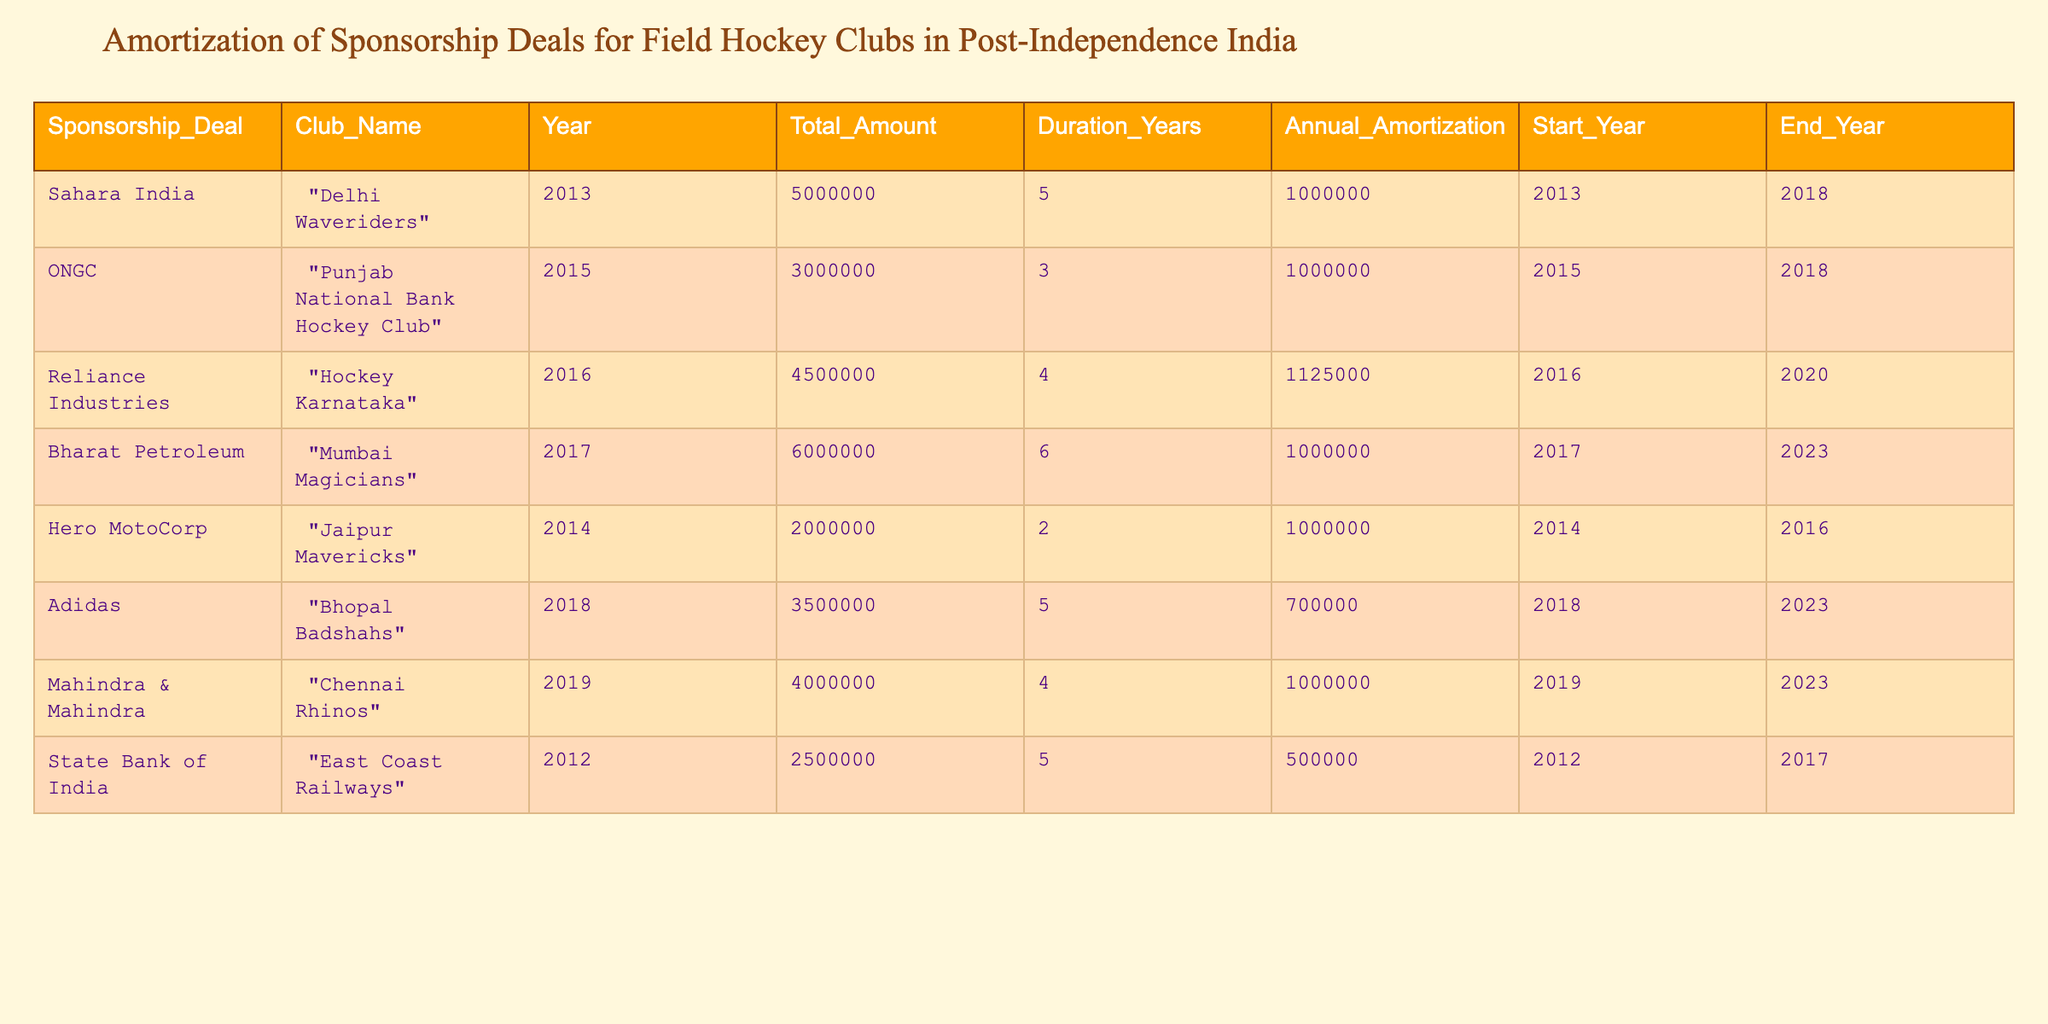What is the total sponsorship amount for the Delhi Waveriders? The table shows that the sponsorship deal for the Delhi Waveriders is with Sahara India, which has a total amount of 5,000,000.
Answer: 5000000 Which club had the longest duration of sponsorship? To determine the longest duration of sponsorship, we examine the 'Duration_Years' column. The maximum value is 6 years for the Mumbai Magicians with Bharat Petroleum.
Answer: Mumbai Magicians Is the annual amortization for Punjab National Bank Hockey Club equal to the total amount divided by the duration? The annual amortization is reported as 1,000,000, and calculating the total amount (3,000,000) divided by the duration (3 years) gives 3,000,000 / 3 = 1,000,000, which matches the reported value.
Answer: Yes What is the average annual amortization across all clubs? The total annual amortization values are (1,000,000 + 1,000,000 + 1,125,000 + 1,000,000 + 1,000,000 + 700,000 + 1,000,000 + 500,000) = 6,325,000, and there are 8 clubs, thus average = 6,325,000 / 8 = 790,625.
Answer: 790625 Which club had a sponsorship deal starting the earliest and what was the year? According to the 'Start_Year' column, the earliest start year is 2012 (for East Coast Railways), making it the club with the earliest sponsorship deal.
Answer: East Coast Railways, 2012 How much total sponsorship amount is attributed to deals that last 5 years? The clubs with a 5-year deal (Delhi Waveriders, East Coast Railways, and Adidas) total to (5,000,000 + 2,500,000 + 3,500,000) = 11,000,000.
Answer: 11000000 Did any club have an annual amortization of less than 700,000? Reviewing the annual amortization values, the Chennai Rhinos and East Coast Railways both show amounts below 700,000.
Answer: Yes What is the difference between the maximum and minimum annual amortization values? The maximum annual amortization is 1,125,000 for Hockey Karnataka, and the minimum is 500,000 for East Coast Railways. Therefore, the difference is 1,125,000 - 500,000 = 625,000.
Answer: 625000 